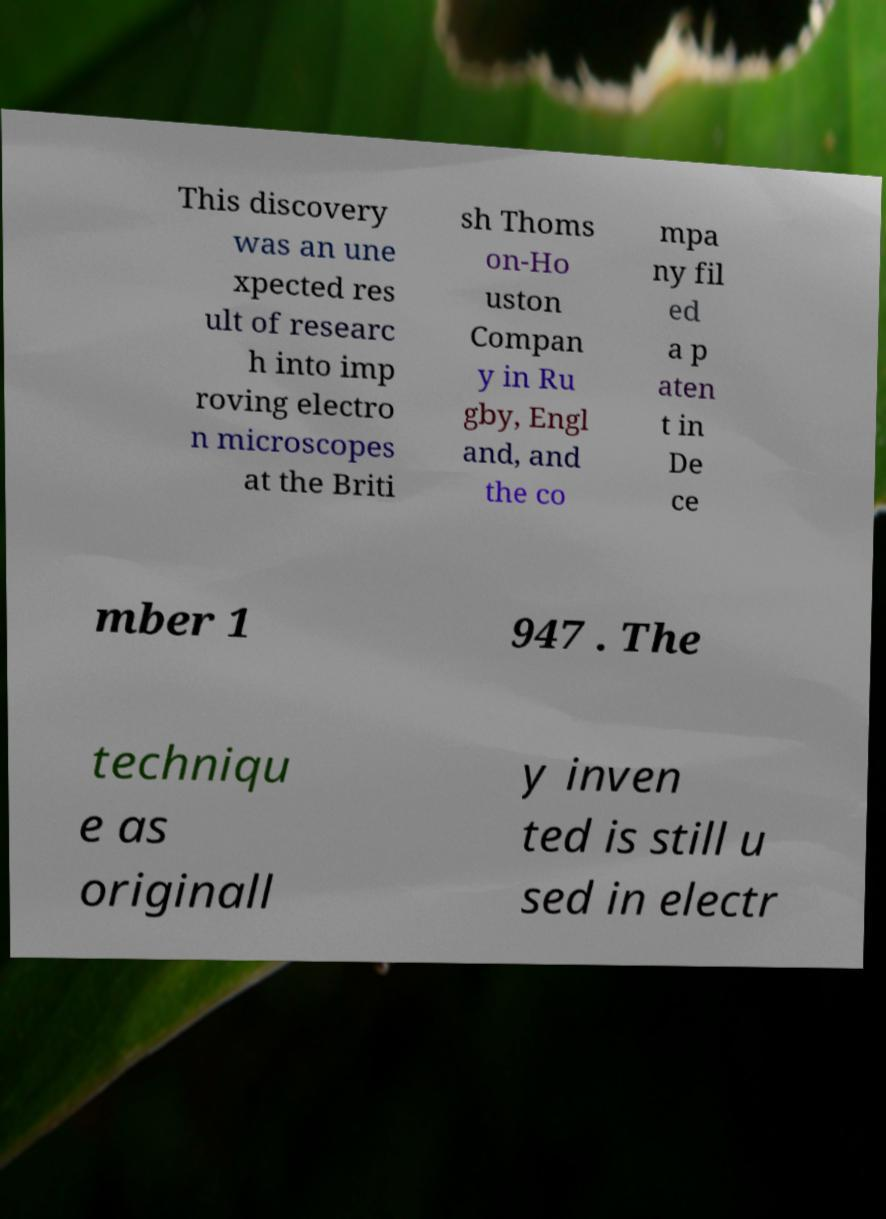Please read and relay the text visible in this image. What does it say? This discovery was an une xpected res ult of researc h into imp roving electro n microscopes at the Briti sh Thoms on-Ho uston Compan y in Ru gby, Engl and, and the co mpa ny fil ed a p aten t in De ce mber 1 947 . The techniqu e as originall y inven ted is still u sed in electr 